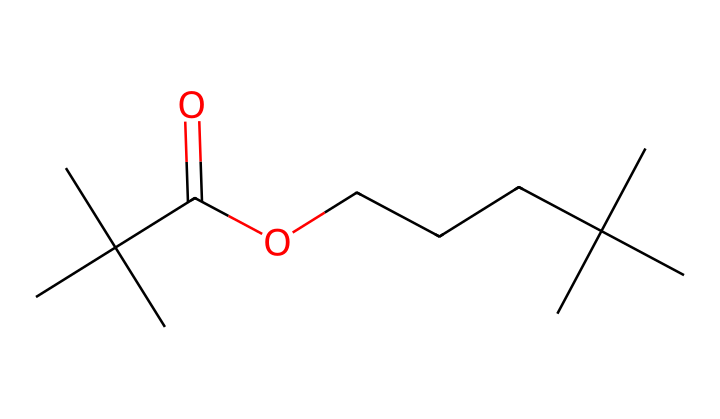what is the main functional group present in this chemical? The structure shows a carboxylic acid group (represented by -COOH) near the end of the chain. This functional group is characterized by a carbon double-bonded to an oxygen and also bonded to a hydroxyl group.
Answer: carboxylic acid how many carbon atoms are in this molecule? By counting the number of 'C' atoms in both the branched and linear portions of the chemical structure, we find there are 15 carbon atoms total.
Answer: 15 what type of intermolecular forces are likely present in this compound? The presence of a carboxylic acid group indicates that hydrogen bonding is possible due to the -OH bond. Additionally, van der Waals forces would be present due to the hydrocarbon chains.
Answer: hydrogen bonding is this molecule hydrophilic or hydrophobic? The carboxylic acid group introduces a polar region, making the molecule more hydrophilic, while the long hydrocarbon chains are hydrophobic. However, the presence of the polar functional group prevails, suggesting overall hydrophilicity.
Answer: hydrophilic how does this structure influence its behavior as a non-Newtonian fluid? The branched structure and functional groups allow for the formation of entangled networks of polymer chains, contributing to the non-Newtonian properties such as shear-thinning behavior when stress is applied, changing viscosity under force.
Answer: shear-thinning behavior what role does the length of the carbon chain play in its physical properties? Longer carbon chains generally increase hydrophobic character and affect viscosity; in this case, they help control the flexibility and the overall mechanical properties of the polymer in clothing applications.
Answer: flexibility what makes this chemical suitable for high-performance athletic clothing? The combination of flexibility, moisture management from hydrophilicity, and the ability to stretch and return to original shapes under physical stress makes this chemical ideal for athletic clothing, enhancing comfort and performance.
Answer: comfort and performance 